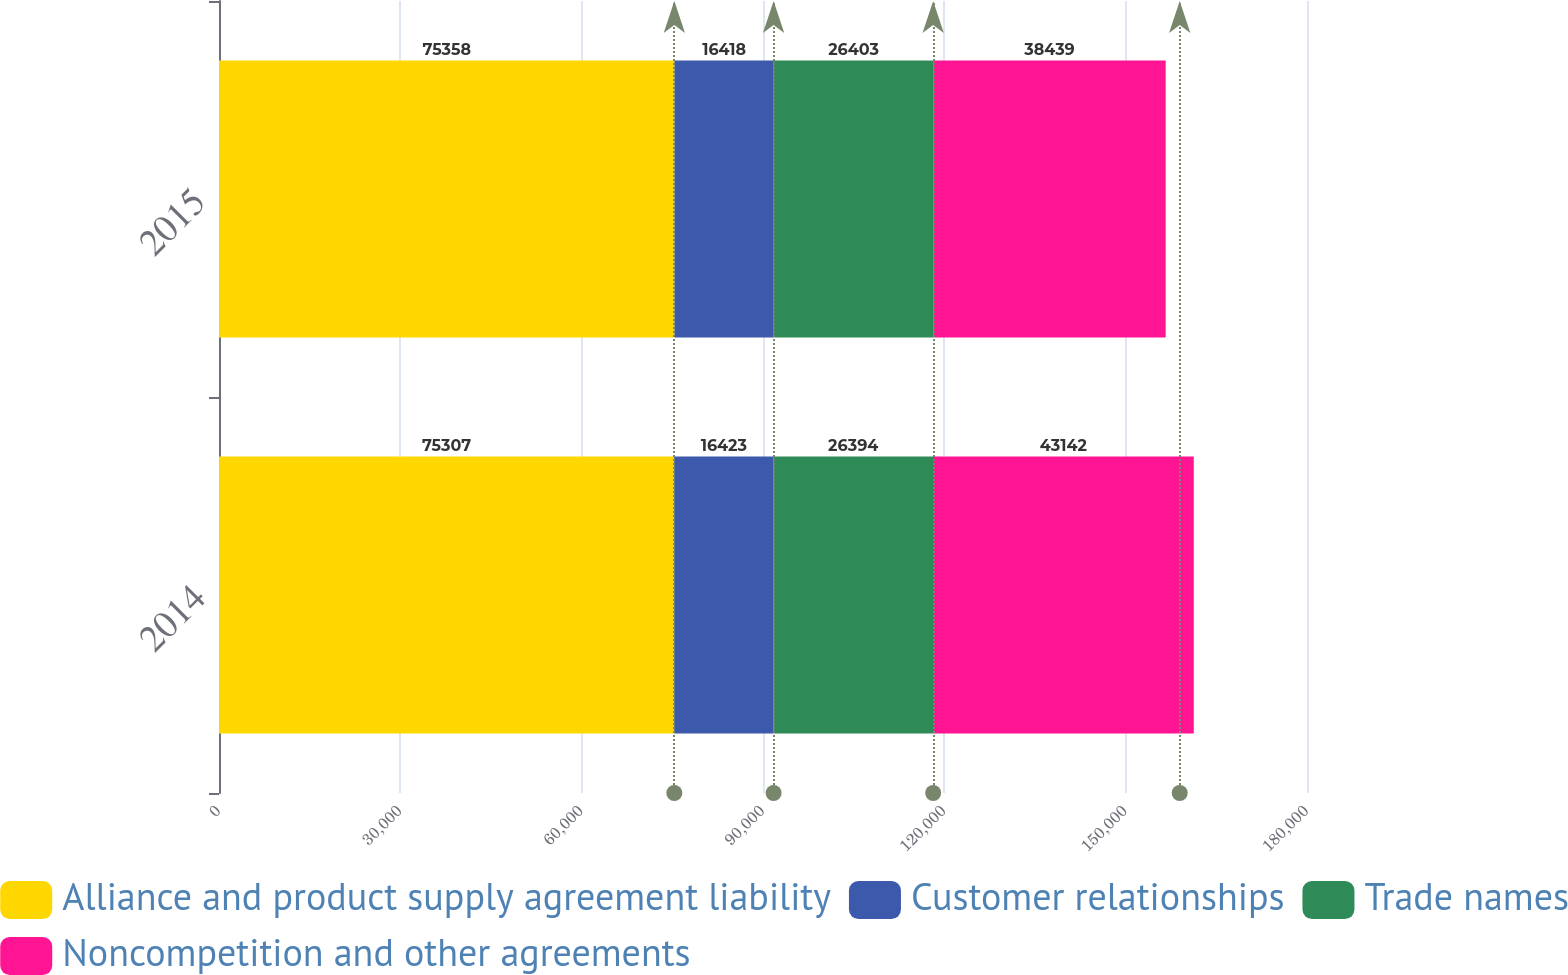Convert chart to OTSL. <chart><loc_0><loc_0><loc_500><loc_500><stacked_bar_chart><ecel><fcel>2014<fcel>2015<nl><fcel>Alliance and product supply agreement liability<fcel>75307<fcel>75358<nl><fcel>Customer relationships<fcel>16423<fcel>16418<nl><fcel>Trade names<fcel>26394<fcel>26403<nl><fcel>Noncompetition and other agreements<fcel>43142<fcel>38439<nl></chart> 